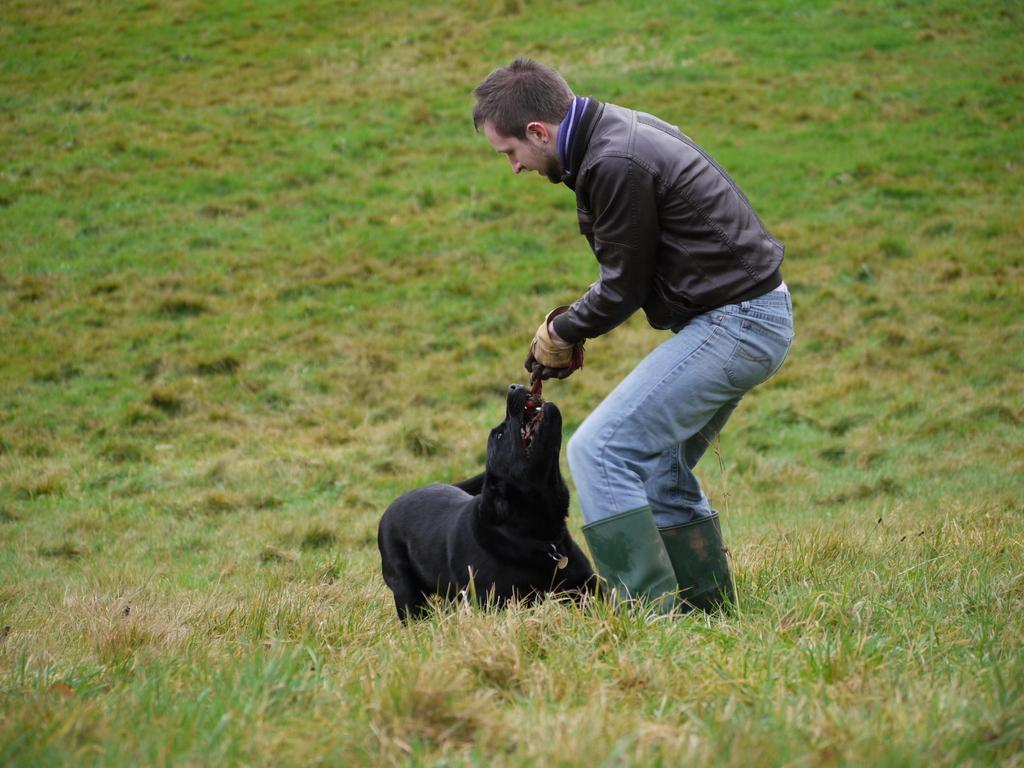What type of vegetation is present in the image? There is fresh green grass in the image. Who is present in the image? There is a man in the image. What is the man doing in the image? The man is playing with a black dog. What clothing items is the man wearing in the image? The man is wearing a scarf and a black jacket. Where is the stage located in the image? There is no stage present in the image. How many trains can be seen in the image? There are no trains present in the image. 